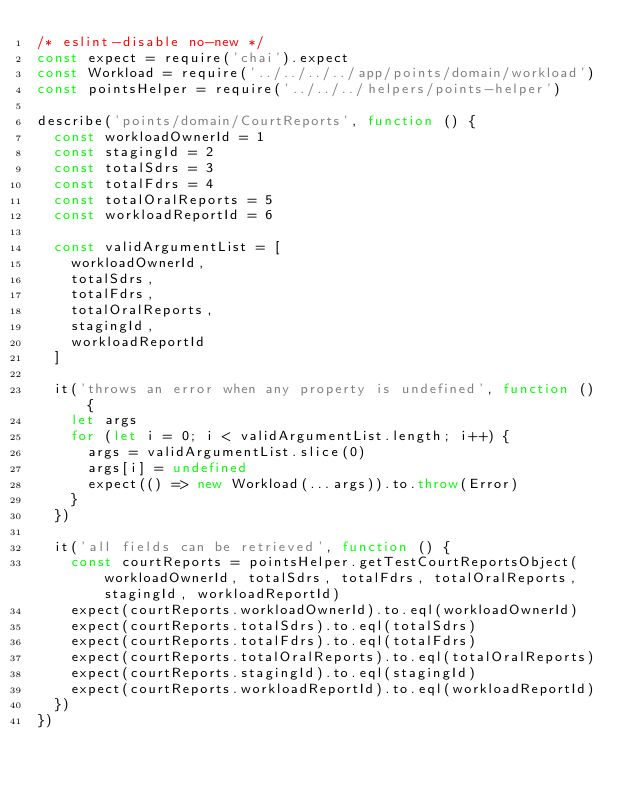Convert code to text. <code><loc_0><loc_0><loc_500><loc_500><_JavaScript_>/* eslint-disable no-new */
const expect = require('chai').expect
const Workload = require('../../../../app/points/domain/workload')
const pointsHelper = require('../../../helpers/points-helper')

describe('points/domain/CourtReports', function () {
  const workloadOwnerId = 1
  const stagingId = 2
  const totalSdrs = 3
  const totalFdrs = 4
  const totalOralReports = 5
  const workloadReportId = 6

  const validArgumentList = [
    workloadOwnerId,
    totalSdrs,
    totalFdrs,
    totalOralReports,
    stagingId,
    workloadReportId
  ]

  it('throws an error when any property is undefined', function () {
    let args
    for (let i = 0; i < validArgumentList.length; i++) {
      args = validArgumentList.slice(0)
      args[i] = undefined
      expect(() => new Workload(...args)).to.throw(Error)
    }
  })

  it('all fields can be retrieved', function () {
    const courtReports = pointsHelper.getTestCourtReportsObject(workloadOwnerId, totalSdrs, totalFdrs, totalOralReports, stagingId, workloadReportId)
    expect(courtReports.workloadOwnerId).to.eql(workloadOwnerId)
    expect(courtReports.totalSdrs).to.eql(totalSdrs)
    expect(courtReports.totalFdrs).to.eql(totalFdrs)
    expect(courtReports.totalOralReports).to.eql(totalOralReports)
    expect(courtReports.stagingId).to.eql(stagingId)
    expect(courtReports.workloadReportId).to.eql(workloadReportId)
  })
})
</code> 